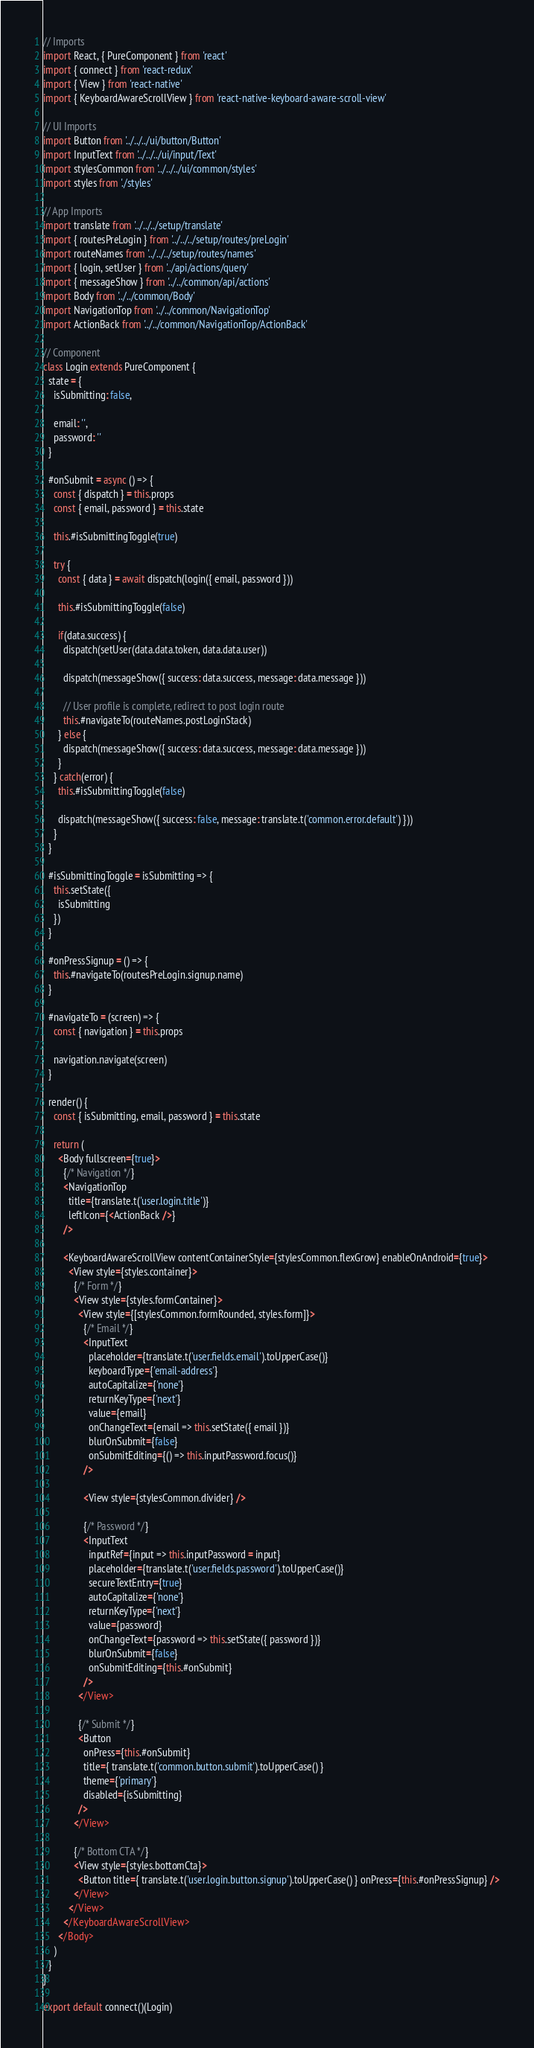<code> <loc_0><loc_0><loc_500><loc_500><_JavaScript_>// Imports
import React, { PureComponent } from 'react'
import { connect } from 'react-redux'
import { View } from 'react-native'
import { KeyboardAwareScrollView } from 'react-native-keyboard-aware-scroll-view'

// UI Imports
import Button from '../../../ui/button/Button'
import InputText from '../../../ui/input/Text'
import stylesCommon from '../../../ui/common/styles'
import styles from './styles'

// App Imports
import translate from '../../../setup/translate'
import { routesPreLogin } from '../../../setup/routes/preLogin'
import routeNames from '../../../setup/routes/names'
import { login, setUser } from '../api/actions/query'
import { messageShow } from '../../common/api/actions'
import Body from '../../common/Body'
import NavigationTop from '../../common/NavigationTop'
import ActionBack from '../../common/NavigationTop/ActionBack'

// Component
class Login extends PureComponent {
  state = {
    isSubmitting: false,

    email: '',
    password: ''
  }

  #onSubmit = async () => {
    const { dispatch } = this.props
    const { email, password } = this.state

    this.#isSubmittingToggle(true)

    try {
      const { data } = await dispatch(login({ email, password }))

      this.#isSubmittingToggle(false)

      if(data.success) {
        dispatch(setUser(data.data.token, data.data.user))

        dispatch(messageShow({ success: data.success, message: data.message }))

        // User profile is complete, redirect to post login route
        this.#navigateTo(routeNames.postLoginStack)
      } else {
        dispatch(messageShow({ success: data.success, message: data.message }))
      }
    } catch(error) {
      this.#isSubmittingToggle(false)

      dispatch(messageShow({ success: false, message: translate.t('common.error.default') }))
    }
  }

  #isSubmittingToggle = isSubmitting => {
    this.setState({
      isSubmitting
    })
  }

  #onPressSignup = () => {
    this.#navigateTo(routesPreLogin.signup.name)
  }

  #navigateTo = (screen) => {
    const { navigation } = this.props

    navigation.navigate(screen)
  }

  render() {
    const { isSubmitting, email, password } = this.state

    return (
      <Body fullscreen={true}>
        {/* Navigation */}
        <NavigationTop
          title={translate.t('user.login.title')}
          leftIcon={<ActionBack />}
        />

        <KeyboardAwareScrollView contentContainerStyle={stylesCommon.flexGrow} enableOnAndroid={true}>
          <View style={styles.container}>
            {/* Form */}
            <View style={styles.formContainer}>
              <View style={[stylesCommon.formRounded, styles.form]}>
                {/* Email */}
                <InputText
                  placeholder={translate.t('user.fields.email').toUpperCase()}
                  keyboardType={'email-address'}
                  autoCapitalize={'none'}
                  returnKeyType={'next'}
                  value={email}
                  onChangeText={email => this.setState({ email })}
                  blurOnSubmit={false}
                  onSubmitEditing={() => this.inputPassword.focus()}
                />

                <View style={stylesCommon.divider} />

                {/* Password */}
                <InputText
                  inputRef={input => this.inputPassword = input}
                  placeholder={translate.t('user.fields.password').toUpperCase()}
                  secureTextEntry={true}
                  autoCapitalize={'none'}
                  returnKeyType={'next'}
                  value={password}
                  onChangeText={password => this.setState({ password })}
                  blurOnSubmit={false}
                  onSubmitEditing={this.#onSubmit}
                />
              </View>

              {/* Submit */}
              <Button
                onPress={this.#onSubmit}
                title={ translate.t('common.button.submit').toUpperCase() }
                theme={'primary'}
                disabled={isSubmitting}
              />
            </View>

            {/* Bottom CTA */}
            <View style={styles.bottomCta}>
              <Button title={ translate.t('user.login.button.signup').toUpperCase() } onPress={this.#onPressSignup} />
            </View>
          </View>
        </KeyboardAwareScrollView>
      </Body>
    )
  }
}

export default connect()(Login)
</code> 